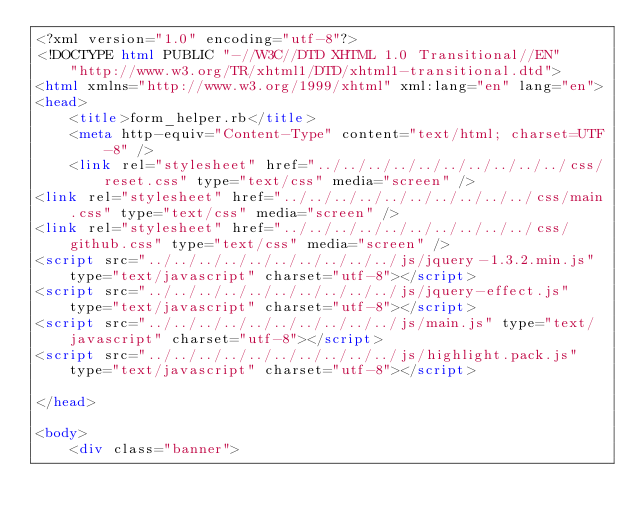<code> <loc_0><loc_0><loc_500><loc_500><_HTML_><?xml version="1.0" encoding="utf-8"?>
<!DOCTYPE html PUBLIC "-//W3C//DTD XHTML 1.0 Transitional//EN"
    "http://www.w3.org/TR/xhtml1/DTD/xhtml1-transitional.dtd">
<html xmlns="http://www.w3.org/1999/xhtml" xml:lang="en" lang="en">
<head>
    <title>form_helper.rb</title>
    <meta http-equiv="Content-Type" content="text/html; charset=UTF-8" />
    <link rel="stylesheet" href="../../../../../../../../../../css/reset.css" type="text/css" media="screen" />
<link rel="stylesheet" href="../../../../../../../../../../css/main.css" type="text/css" media="screen" />
<link rel="stylesheet" href="../../../../../../../../../../css/github.css" type="text/css" media="screen" />
<script src="../../../../../../../../../../js/jquery-1.3.2.min.js" type="text/javascript" charset="utf-8"></script>
<script src="../../../../../../../../../../js/jquery-effect.js" type="text/javascript" charset="utf-8"></script>
<script src="../../../../../../../../../../js/main.js" type="text/javascript" charset="utf-8"></script>
<script src="../../../../../../../../../../js/highlight.pack.js" type="text/javascript" charset="utf-8"></script>

</head>

<body>     
    <div class="banner">
        </code> 